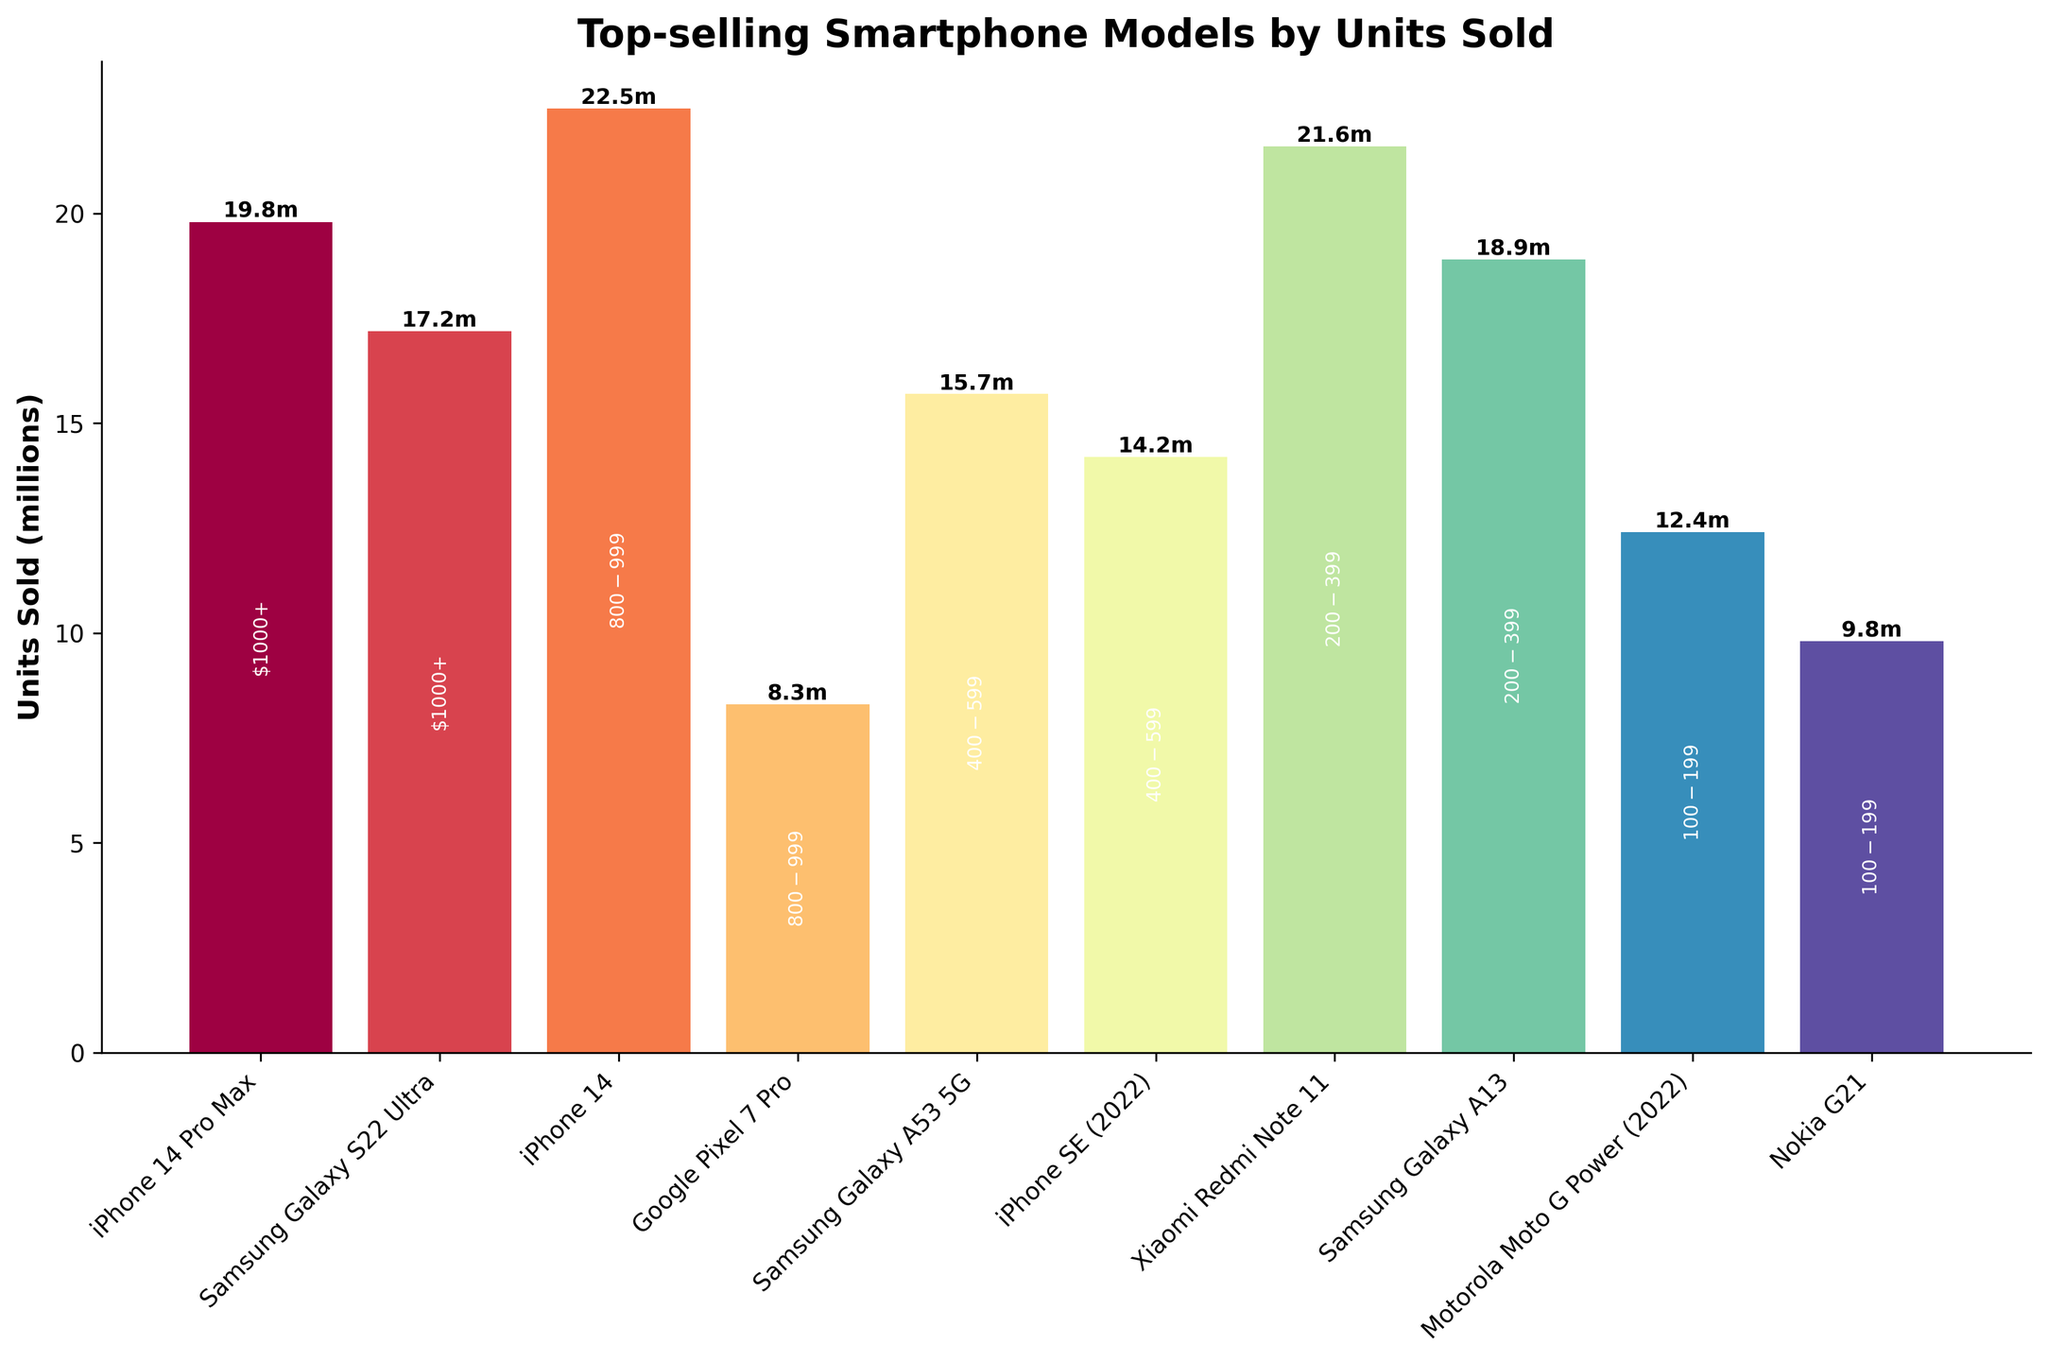Which smartphone model in the $800-$999 price range sold the most units? The figure displays the units sold for each smartphone model along with their corresponding price ranges. We look for the models within the $800-$999 price range and compare their units sold. The iPhone 14 sold 22.5 million units, while the Google Pixel 7 Pro sold 8.3 million units. Thus, the iPhone 14 sold the most units in this price range.
Answer: iPhone 14 Which smartphone model sold more units, the Samsung Galaxy A53 5G or the iPhone SE (2022)? From the figure, we locate the bars for both the Samsung Galaxy A53 5G and the iPhone SE (2022). The Samsung Galaxy A53 5G sold 15.7 million units, whereas the iPhone SE (2022) sold 14.2 million units. Comparing the two, the Samsung Galaxy A53 5G sold more units.
Answer: Samsung Galaxy A53 5G How much more did the Xiaomi Redmi Note 11 sell compared to the Samsung Galaxy A13? The figure provides units sold for both models; the Xiaomi Redmi Note 11 sold 21.6 million units, and the Samsung Galaxy A13 sold 18.9 million units. The difference is calculated as 21.6 - 18.9 = 2.7 million units.
Answer: 2.7 million units Which price range had the highest total units sold? To determine this, we sum the units sold within each price range:
- $1000+: 19.8 (iPhone 14 Pro Max) + 17.2 (Samsung Galaxy S22 Ultra) = 37
- $800-$999: 22.5 (iPhone 14) + 8.3 (Google Pixel 7 Pro) = 30.8
- $400-$599: 15.7 (Samsung Galaxy A53 5G) + 14.2 (iPhone SE (2022)) = 29.9
- $200-$399: 21.6 (Xiaomi Redmi Note 11) + 18.9 (Samsung Galaxy A13) = 40.5
- $100-$199: 12.4 (Motorola Moto G Power (2022)) + 9.8 (Nokia G21) = 22.2
The $200-$399 price range has the highest total units sold.
Answer: $200-$399 What is the average number of units sold across all models in the figure? We sum the units sold for all models and then divide by the number of models: (19.8 + 17.2 + 22.5 + 8.3 + 15.7 + 14.2 + 21.6 + 18.9 + 12.4 + 9.8) / 10 = 16.04 million units.
Answer: 16.04 million units Which model’s bar is the tallest and what is its height? The tallest bar in the figure corresponds to the model with the highest units sold. By observation, the iPhone 14 has the tallest bar with a height of 22.5 million units.
Answer: iPhone 14, 22.5 million units Between the iPhone 14 Pro Max and the Samsung Galaxy S22 Ultra, which model sold fewer units and by how many? From the figure, the iPhone 14 Pro Max sold 19.8 million units, and the Samsung Galaxy S22 Ultra sold 17.2 million units. The difference is 19.8 - 17.2 = 2.6 million units, indicating the Samsung Galaxy S22 Ultra sold fewer units by this amount.
Answer: Samsung Galaxy S22 Ultra, 2.6 million units 